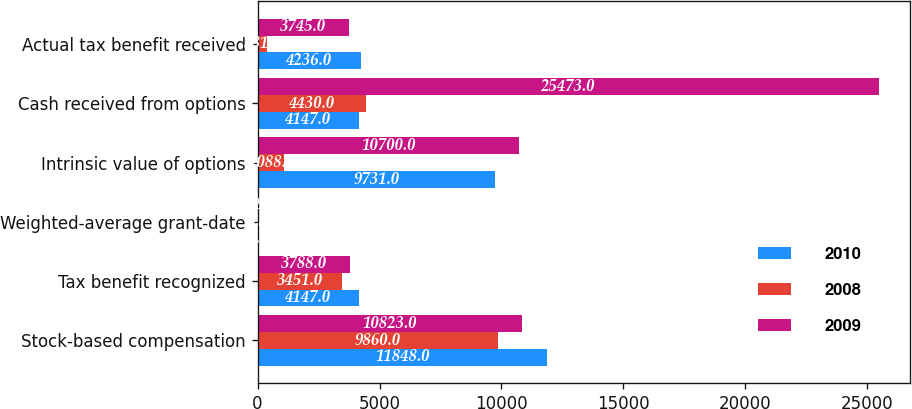<chart> <loc_0><loc_0><loc_500><loc_500><stacked_bar_chart><ecel><fcel>Stock-based compensation<fcel>Tax benefit recognized<fcel>Weighted-average grant-date<fcel>Intrinsic value of options<fcel>Cash received from options<fcel>Actual tax benefit received<nl><fcel>2010<fcel>11848<fcel>4147<fcel>15.53<fcel>9731<fcel>4147<fcel>4236<nl><fcel>2008<fcel>9860<fcel>3451<fcel>5.5<fcel>1088<fcel>4430<fcel>381<nl><fcel>2009<fcel>10823<fcel>3788<fcel>8.87<fcel>10700<fcel>25473<fcel>3745<nl></chart> 